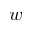<formula> <loc_0><loc_0><loc_500><loc_500>w</formula> 